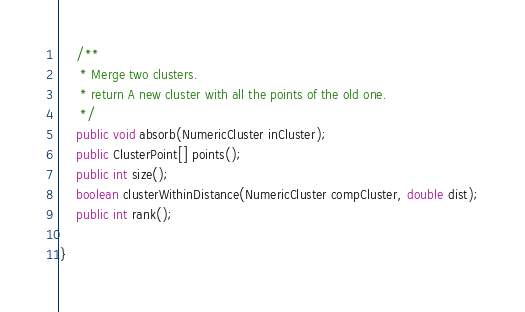Convert code to text. <code><loc_0><loc_0><loc_500><loc_500><_Java_>	/**
	 * Merge two clusters.
	 * return A new cluster with all the points of the old one.
	 */
	public void absorb(NumericCluster inCluster);
	public ClusterPoint[] points();
	public int size();
	boolean clusterWithinDistance(NumericCluster compCluster, double dist);
	public int rank();
	
}
</code> 